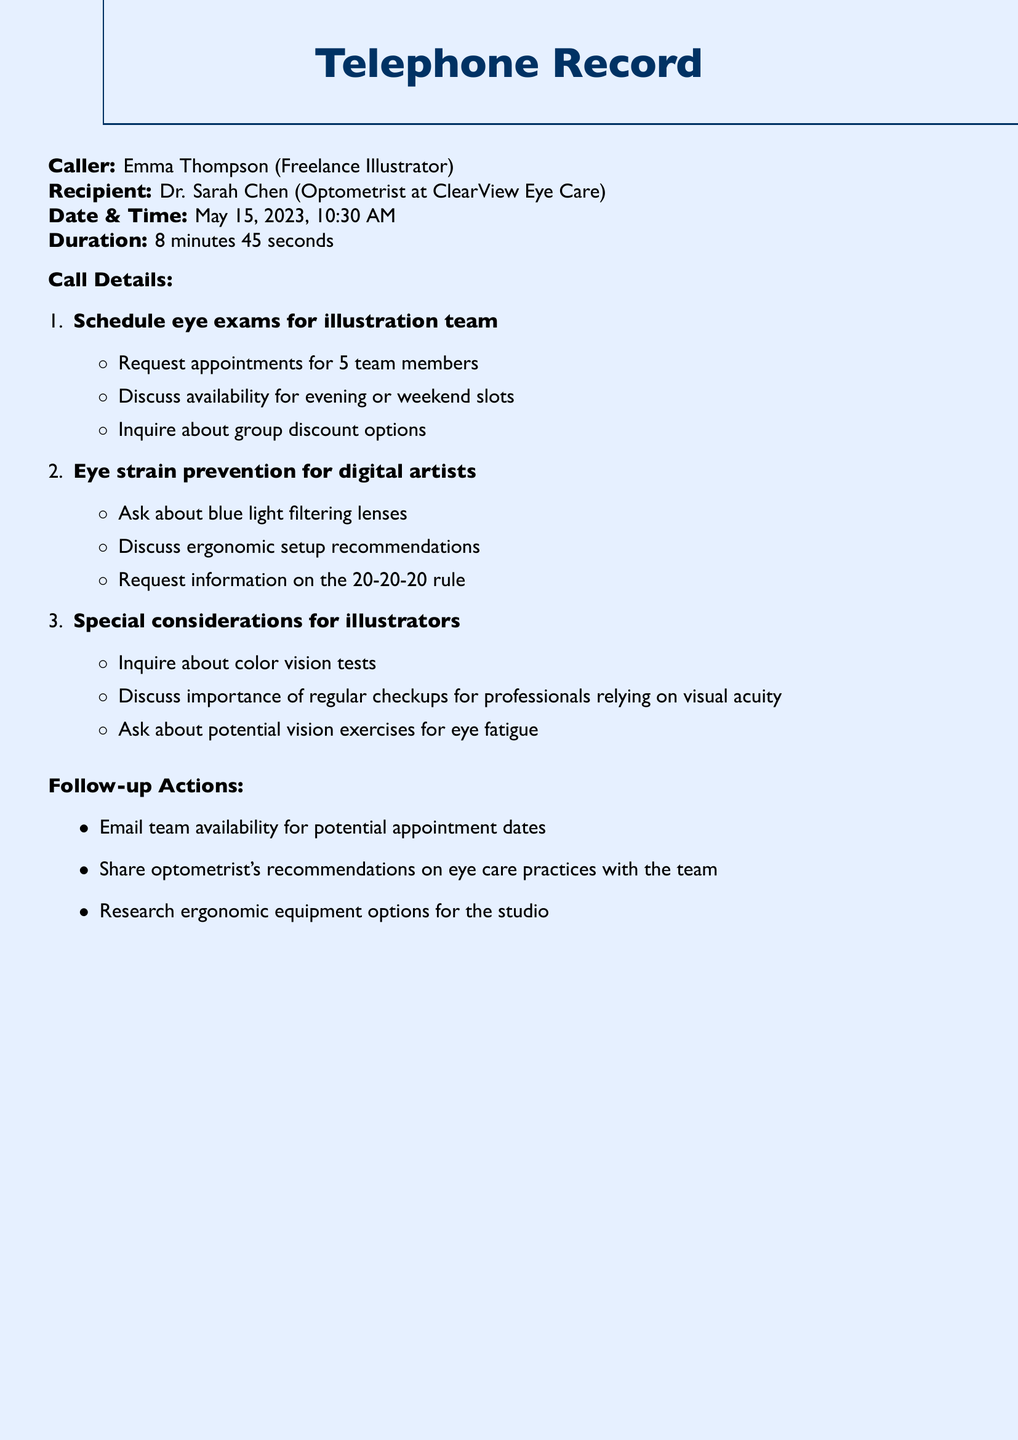What is the call duration? The call duration is provided in the document and is 8 minutes and 45 seconds.
Answer: 8 minutes 45 seconds Who is the recipient of the call? The recipient of the call is specified in the document as Dr. Sarah Chen.
Answer: Dr. Sarah Chen On what date was the call made? The date of the call is mentioned in the document, which is May 15, 2023.
Answer: May 15, 2023 How many team members are requested for eye exams? The document states that appointments are requested for 5 team members.
Answer: 5 What type of lenses is discussed for eye strain prevention? The document mentions a query about blue light filtering lenses as part of eye strain prevention.
Answer: blue light filtering lenses What is one follow-up action noted in the document? The document lists actions to be taken after the call; one of them is to email team availability.
Answer: Email team availability What rule is mentioned for eye care practices? The document refers to the 20-20-20 rule in the context of eye care.
Answer: 20-20-20 rule What type of tests is inquired about for illustrators? The document includes inquiries about color vision tests specifically for illustrators.
Answer: color vision tests What is the primary purpose of the call? The main purpose of the call is to schedule eye exams for the illustration team.
Answer: Schedule eye exams 